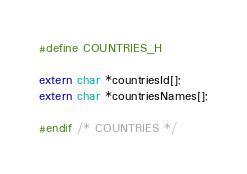Convert code to text. <code><loc_0><loc_0><loc_500><loc_500><_C_>#define COUNTRIES_H

extern char *countriesId[];
extern char *countriesNames[];

#endif /* COUNTRIES */

</code> 